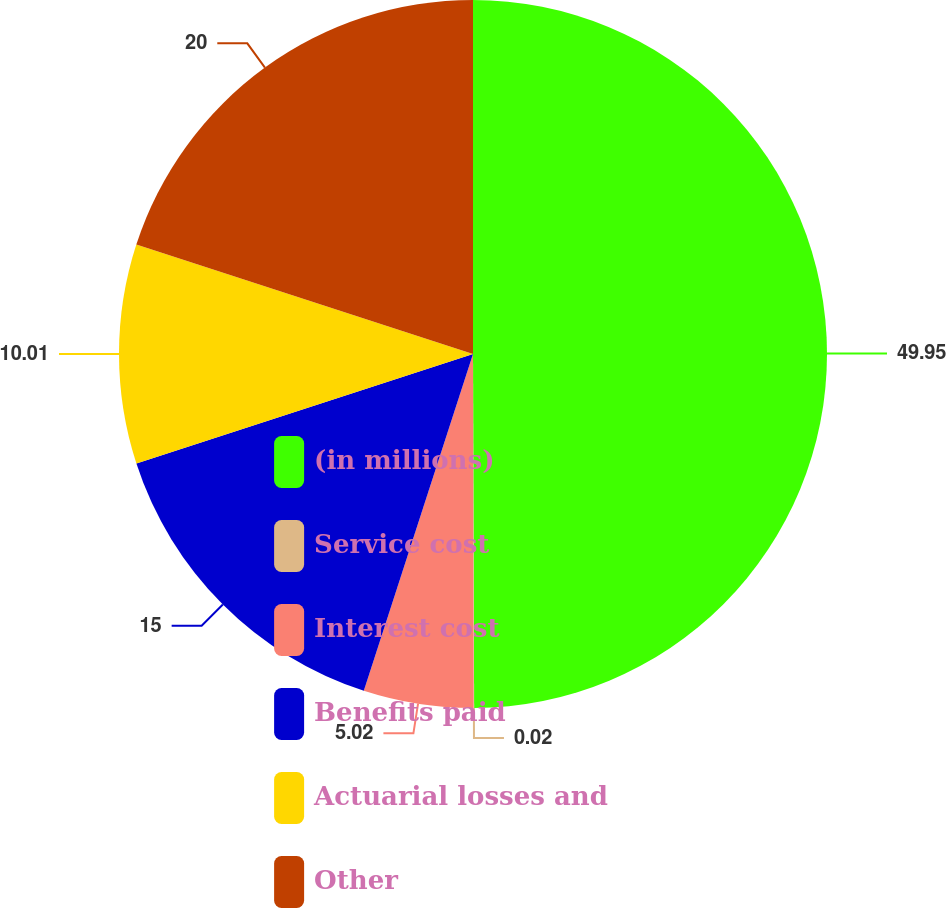Convert chart. <chart><loc_0><loc_0><loc_500><loc_500><pie_chart><fcel>(in millions)<fcel>Service cost<fcel>Interest cost<fcel>Benefits paid<fcel>Actuarial losses and<fcel>Other<nl><fcel>49.95%<fcel>0.02%<fcel>5.02%<fcel>15.0%<fcel>10.01%<fcel>20.0%<nl></chart> 